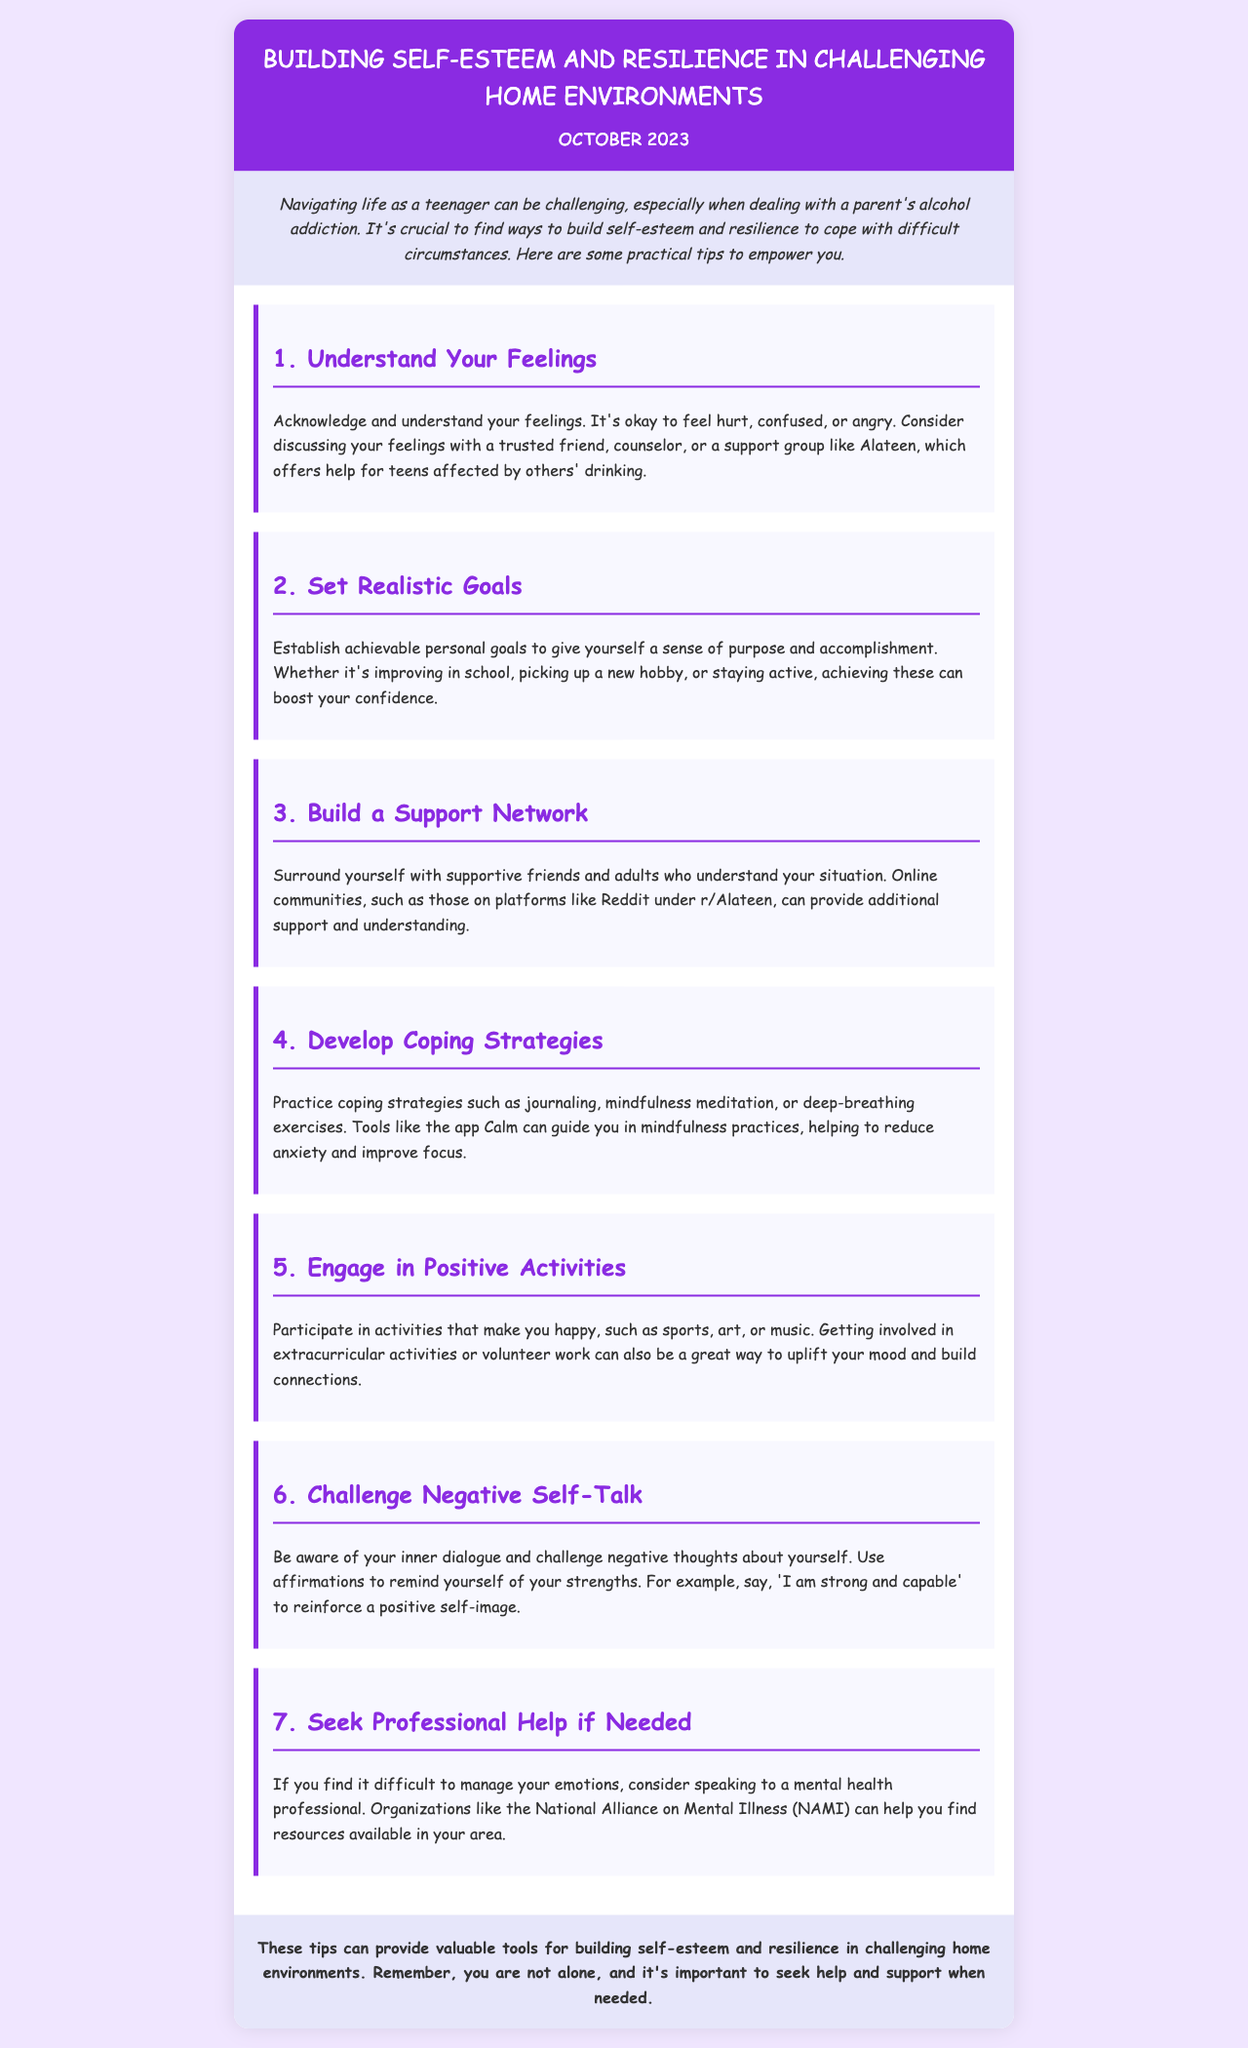what is the title of the newsletter? The title is prominently displayed at the top of the document, indicating the main theme.
Answer: Building Self-Esteem and Resilience in Challenging Home Environments what month and year is the newsletter published? The publication date is noted right below the title in the document.
Answer: October 2023 how many tips are provided in the newsletter? The tips are numbered consecutively in the content section, allowing for easy counting.
Answer: 7 what is the first tip mentioned? The first tip is highlighted as part of the structured content, making it easy to identify.
Answer: Understand Your Feelings who can offer help for teens affected by alcohol? This information is mentioned in the context of providing support resources for teens.
Answer: Alateen what is suggested as a coping strategy? The newsletter provides multiple examples of coping strategies to manage emotional challenges.
Answer: journaling which organization can help find mental health resources? The document lists organizations that support mental health for teens, specifically mentioning one.
Answer: National Alliance on Mental Illness (NAMI) what is a positive activity suggested in the newsletter? The newsletter suggests various activities to uplift one's mood, which are explicitly mentioned.
Answer: sports 